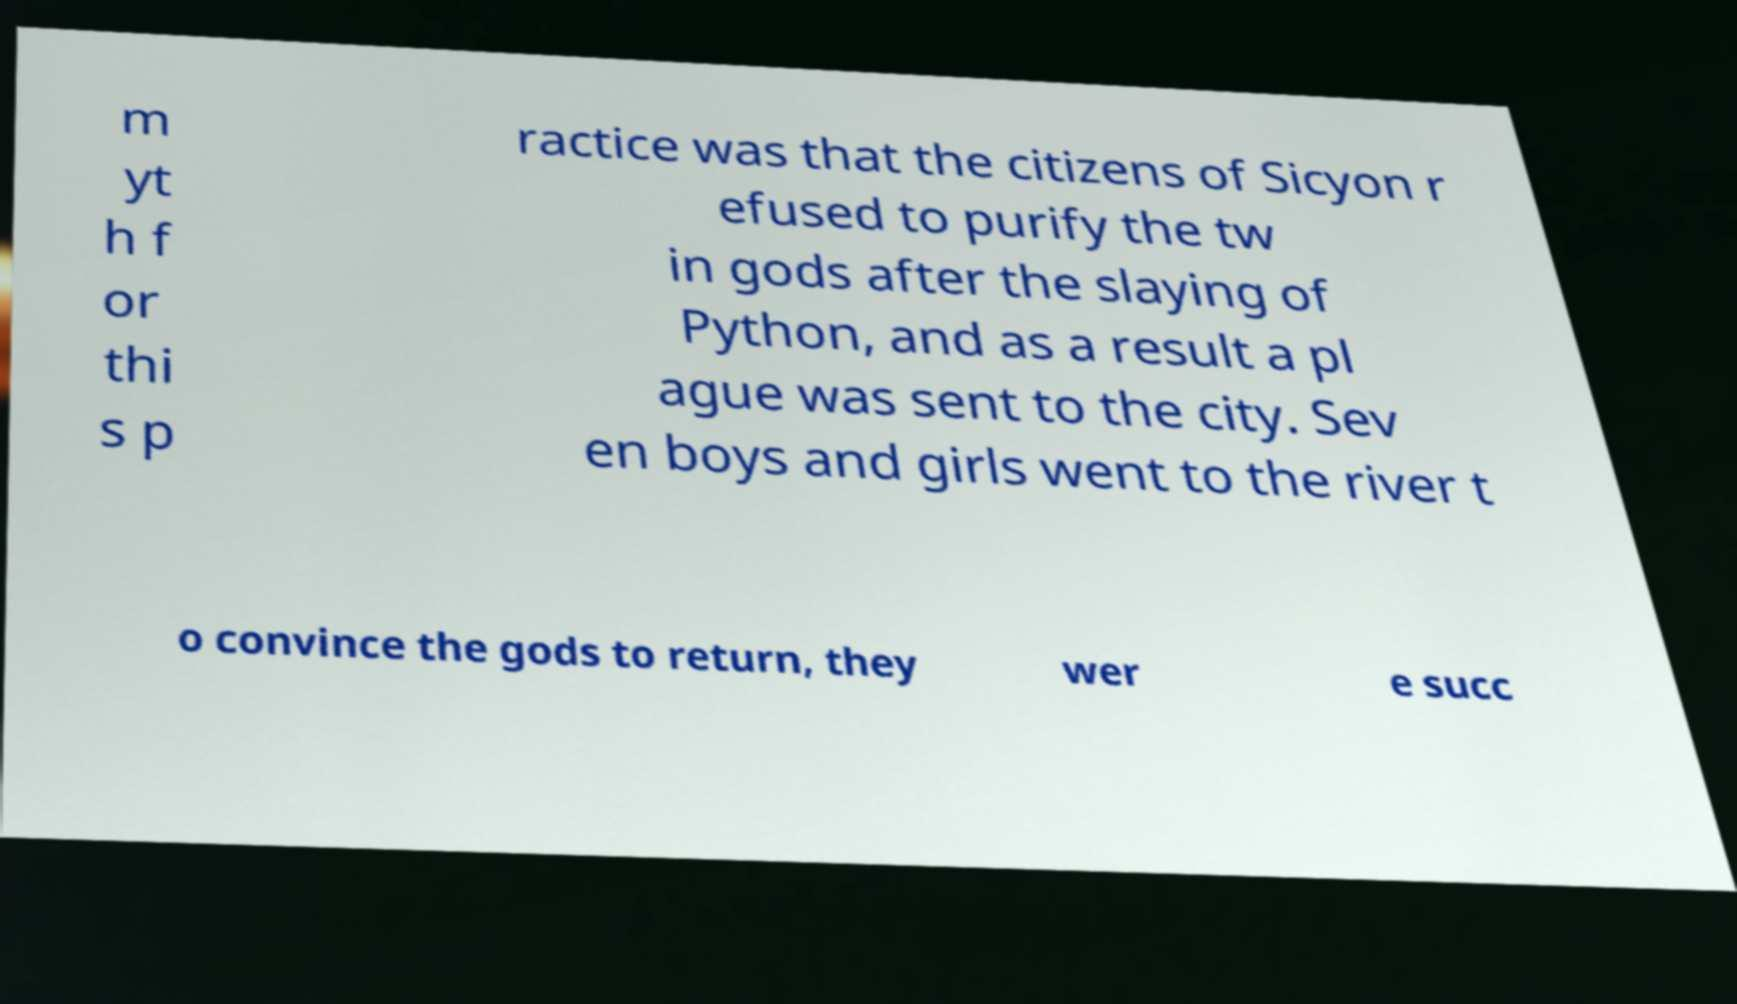Could you extract and type out the text from this image? m yt h f or thi s p ractice was that the citizens of Sicyon r efused to purify the tw in gods after the slaying of Python, and as a result a pl ague was sent to the city. Sev en boys and girls went to the river t o convince the gods to return, they wer e succ 